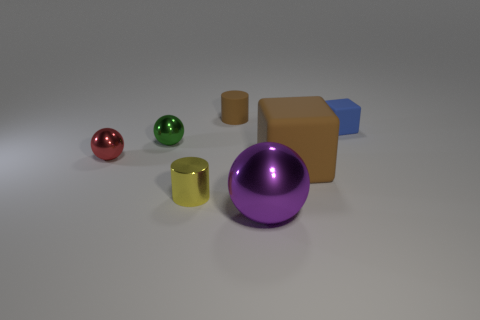Add 3 matte objects. How many objects exist? 10 Subtract all cylinders. How many objects are left? 5 Add 2 purple things. How many purple things are left? 3 Add 5 small red shiny spheres. How many small red shiny spheres exist? 6 Subtract 0 cyan blocks. How many objects are left? 7 Subtract all big brown rubber cubes. Subtract all brown things. How many objects are left? 4 